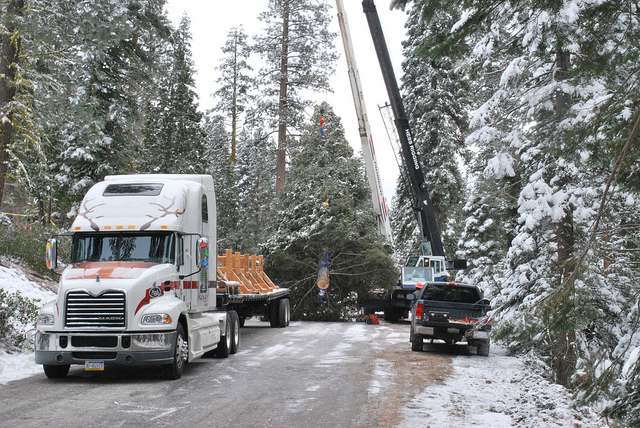<image>What is written on the truck? I am unsure about what is written on the truck. It could be 'mack', 'company', 'ford', or 'mac'. What is written on the truck? I don't know what is written on the truck. It can be seen 'mack', 'company', 'ford' or 'mac'. 